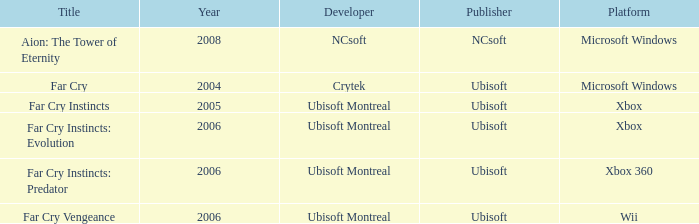What is the typical year with far cry vengeance as the title? 2006.0. 